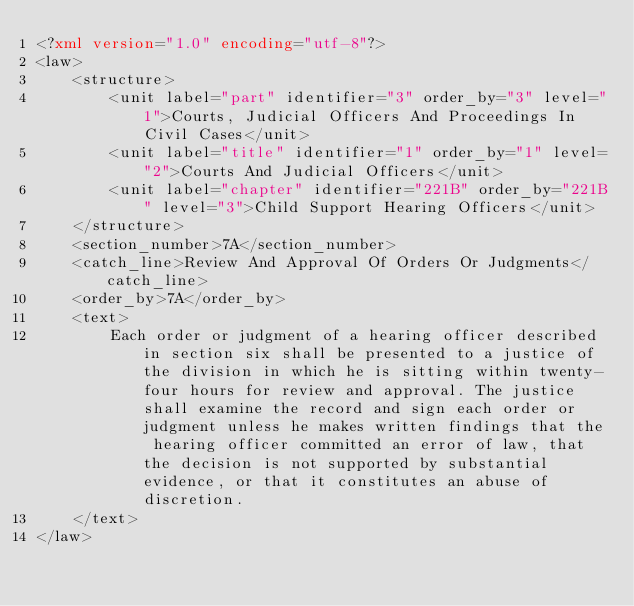<code> <loc_0><loc_0><loc_500><loc_500><_XML_><?xml version="1.0" encoding="utf-8"?>
<law>
    <structure>
        <unit label="part" identifier="3" order_by="3" level="1">Courts, Judicial Officers And Proceedings In Civil Cases</unit>
        <unit label="title" identifier="1" order_by="1" level="2">Courts And Judicial Officers</unit>
        <unit label="chapter" identifier="221B" order_by="221B" level="3">Child Support Hearing Officers</unit>
    </structure>
    <section_number>7A</section_number>
    <catch_line>Review And Approval Of Orders Or Judgments</catch_line>
    <order_by>7A</order_by>
    <text>
        Each order or judgment of a hearing officer described in section six shall be presented to a justice of the division in which he is sitting within twenty-four hours for review and approval. The justice shall examine the record and sign each order or judgment unless he makes written findings that the hearing officer committed an error of law, that the decision is not supported by substantial evidence, or that it constitutes an abuse of discretion.
    </text>
</law></code> 